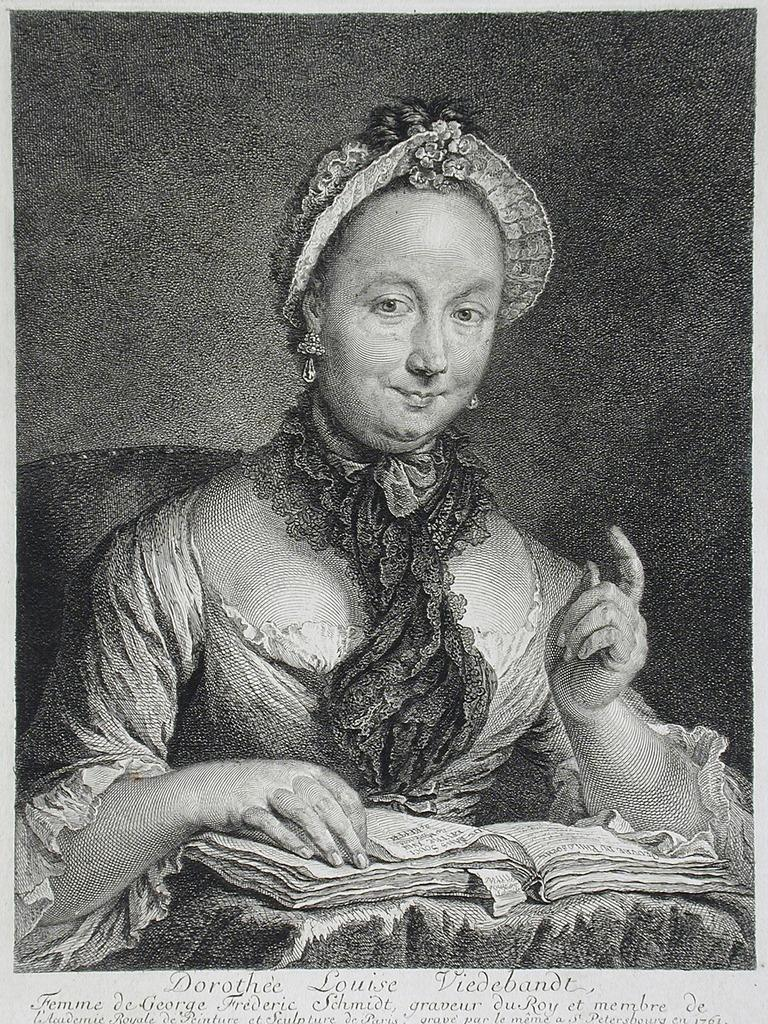What type of artwork is depicted in the image? The image is a painting. Who is the main subject in the painting? There is a girl in the painting. What is the girl doing in the painting? The girl is sitting and smiling. What is the girl holding in her hand? The girl is holding a paper in her hand. What time of day is it in the painting, and how does the girl greet the morning? The time of day is not mentioned in the painting, and there is no indication of the girl greeting the morning. 